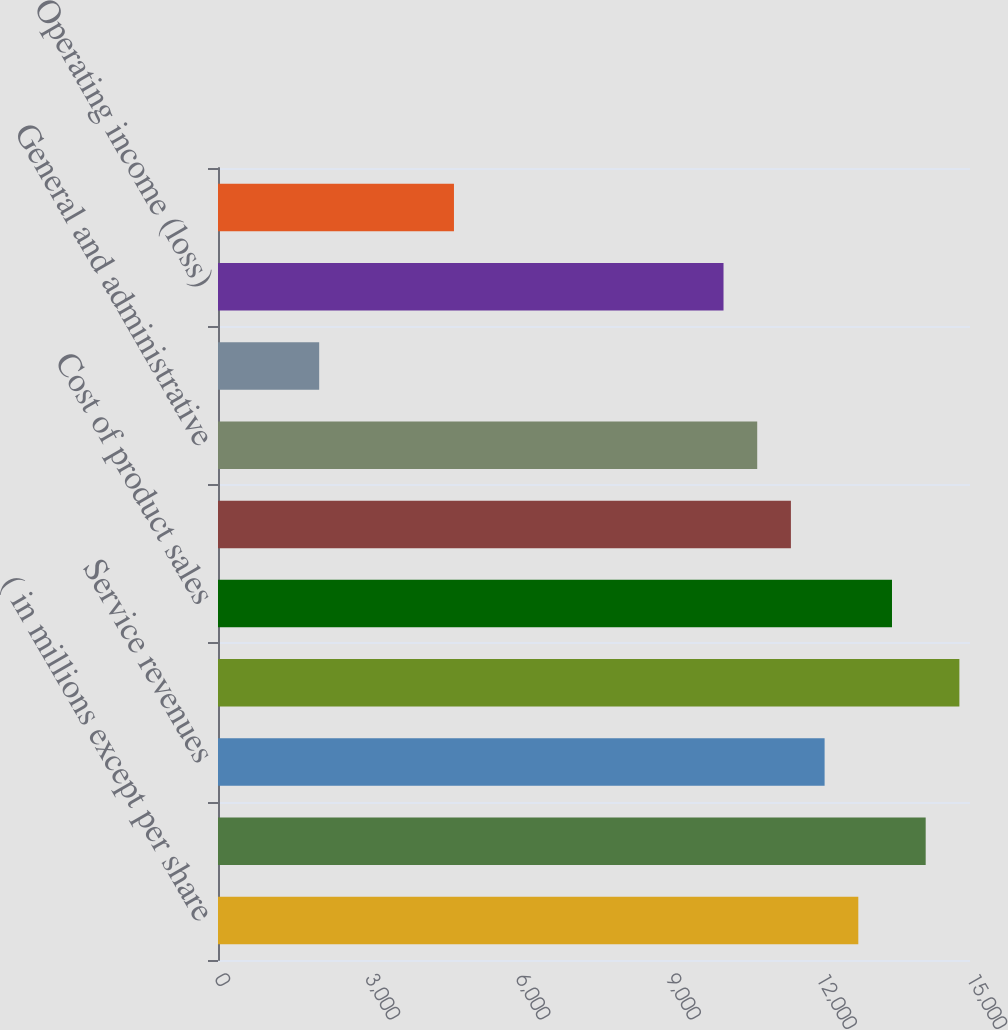Convert chart. <chart><loc_0><loc_0><loc_500><loc_500><bar_chart><fcel>( in millions except per share<fcel>Product sales<fcel>Service revenues<fcel>Total sales and service<fcel>Cost of product sales<fcel>Cost of service revenues<fcel>General and administrative<fcel>Goodwill impairment<fcel>Operating income (loss)<fcel>Interest expense<nl><fcel>12771.9<fcel>14116.1<fcel>12099.8<fcel>14788.2<fcel>13444<fcel>11427.7<fcel>10755.6<fcel>2018.3<fcel>10083.5<fcel>4706.7<nl></chart> 